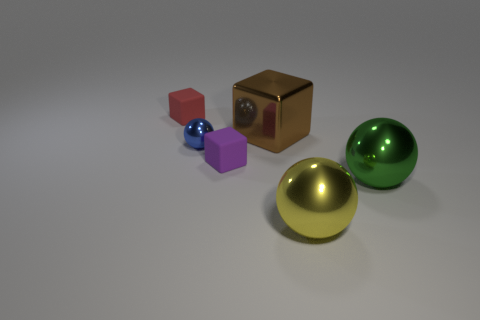The large shiny sphere in front of the green metal thing is what color? yellow 